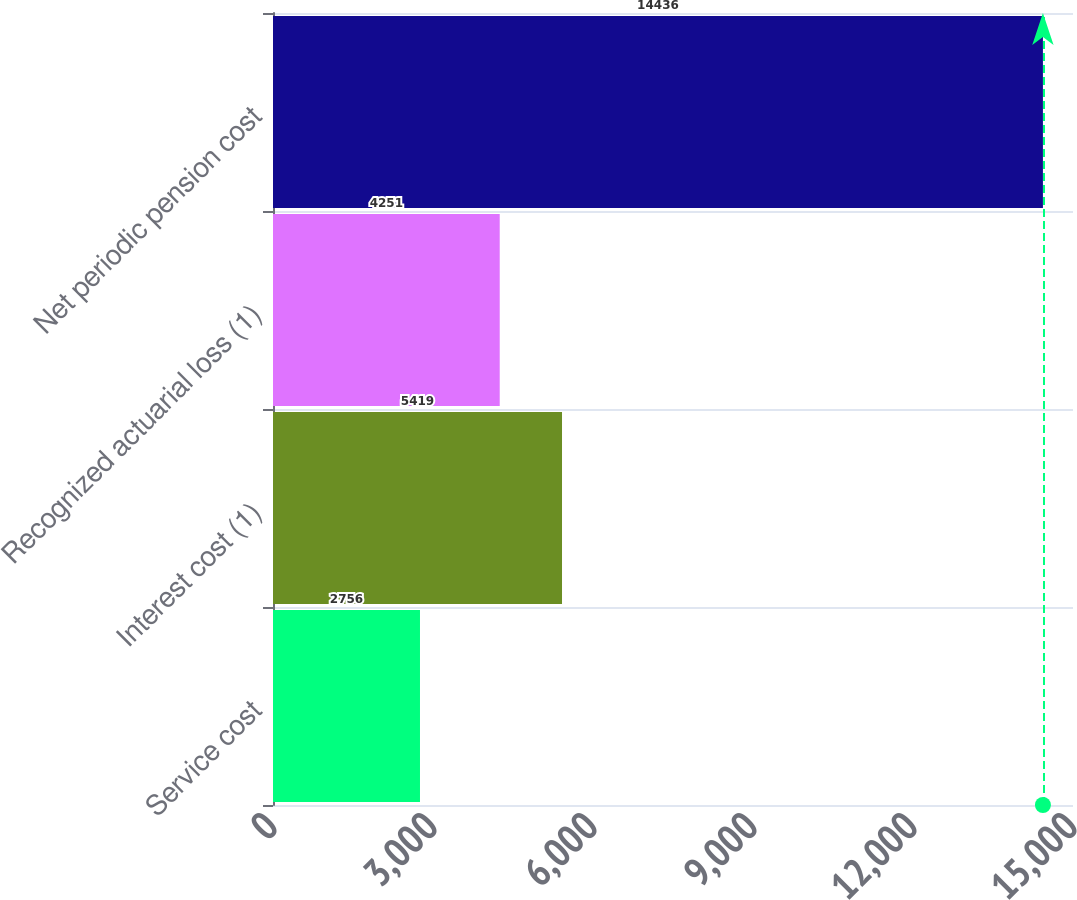<chart> <loc_0><loc_0><loc_500><loc_500><bar_chart><fcel>Service cost<fcel>Interest cost (1)<fcel>Recognized actuarial loss (1)<fcel>Net periodic pension cost<nl><fcel>2756<fcel>5419<fcel>4251<fcel>14436<nl></chart> 